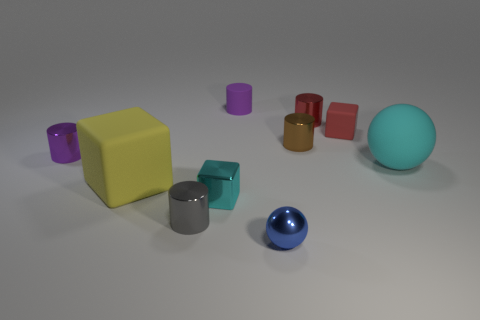Subtract all gray cubes. How many purple cylinders are left? 2 Subtract all small purple matte cylinders. How many cylinders are left? 4 Subtract 3 cylinders. How many cylinders are left? 2 Subtract all gray cylinders. How many cylinders are left? 4 Subtract all red cylinders. Subtract all blue spheres. How many cylinders are left? 4 Subtract all blocks. How many objects are left? 7 Add 9 small purple metal things. How many small purple metal things are left? 10 Add 2 cyan objects. How many cyan objects exist? 4 Subtract 0 yellow cylinders. How many objects are left? 10 Subtract all small cyan rubber blocks. Subtract all tiny cyan shiny blocks. How many objects are left? 9 